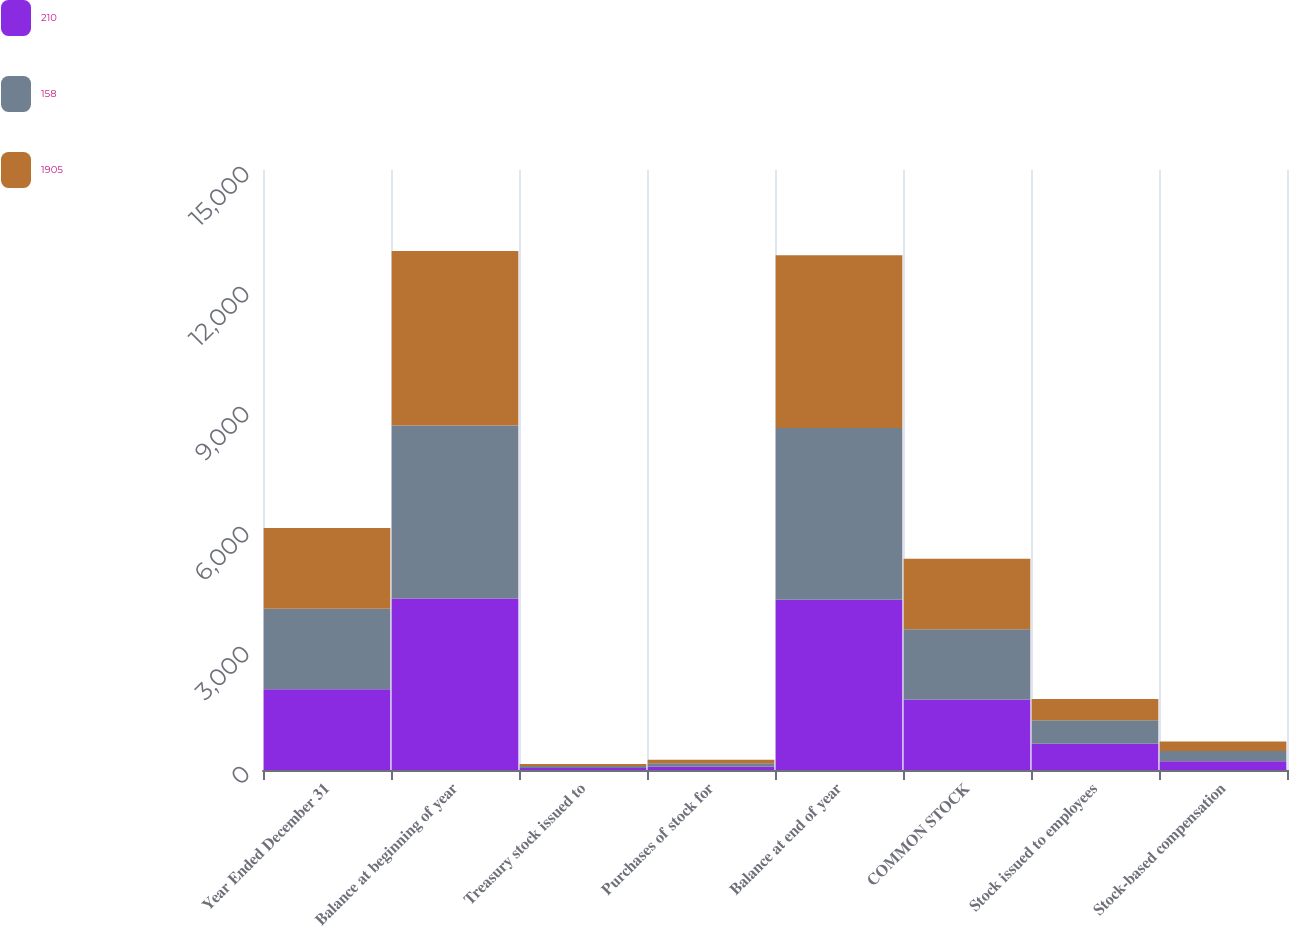<chart> <loc_0><loc_0><loc_500><loc_500><stacked_bar_chart><ecel><fcel>Year Ended December 31<fcel>Balance at beginning of year<fcel>Treasury stock issued to<fcel>Purchases of stock for<fcel>Balance at end of year<fcel>COMMON STOCK<fcel>Stock issued to employees<fcel>Stock-based compensation<nl><fcel>210<fcel>2017<fcel>4288<fcel>53<fcel>82<fcel>4259<fcel>1760<fcel>655<fcel>219<nl><fcel>158<fcel>2016<fcel>4324<fcel>50<fcel>86<fcel>4288<fcel>1760<fcel>589<fcel>258<nl><fcel>1905<fcel>2015<fcel>4366<fcel>44<fcel>86<fcel>4324<fcel>1760<fcel>532<fcel>236<nl></chart> 